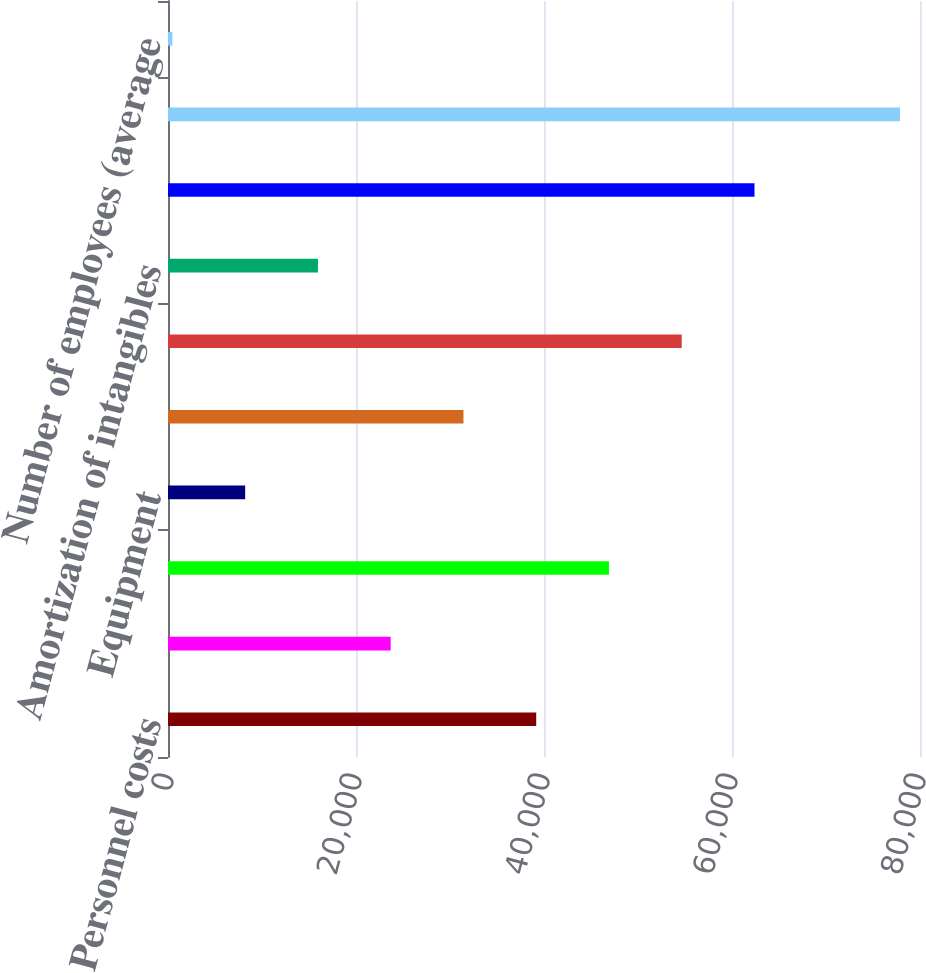Convert chart to OTSL. <chart><loc_0><loc_0><loc_500><loc_500><bar_chart><fcel>Personnel costs<fcel>Outside data processing and<fcel>Net occupancy<fcel>Equipment<fcel>Marketing<fcel>Deposit and other insurance<fcel>Amortization of intangibles<fcel>Professional services<fcel>Total noninterest expense<fcel>Number of employees (average<nl><fcel>39171.5<fcel>23690.9<fcel>46911.8<fcel>8210.3<fcel>31431.2<fcel>54652.1<fcel>15950.6<fcel>62392.4<fcel>77873<fcel>470<nl></chart> 